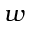Convert formula to latex. <formula><loc_0><loc_0><loc_500><loc_500>w</formula> 